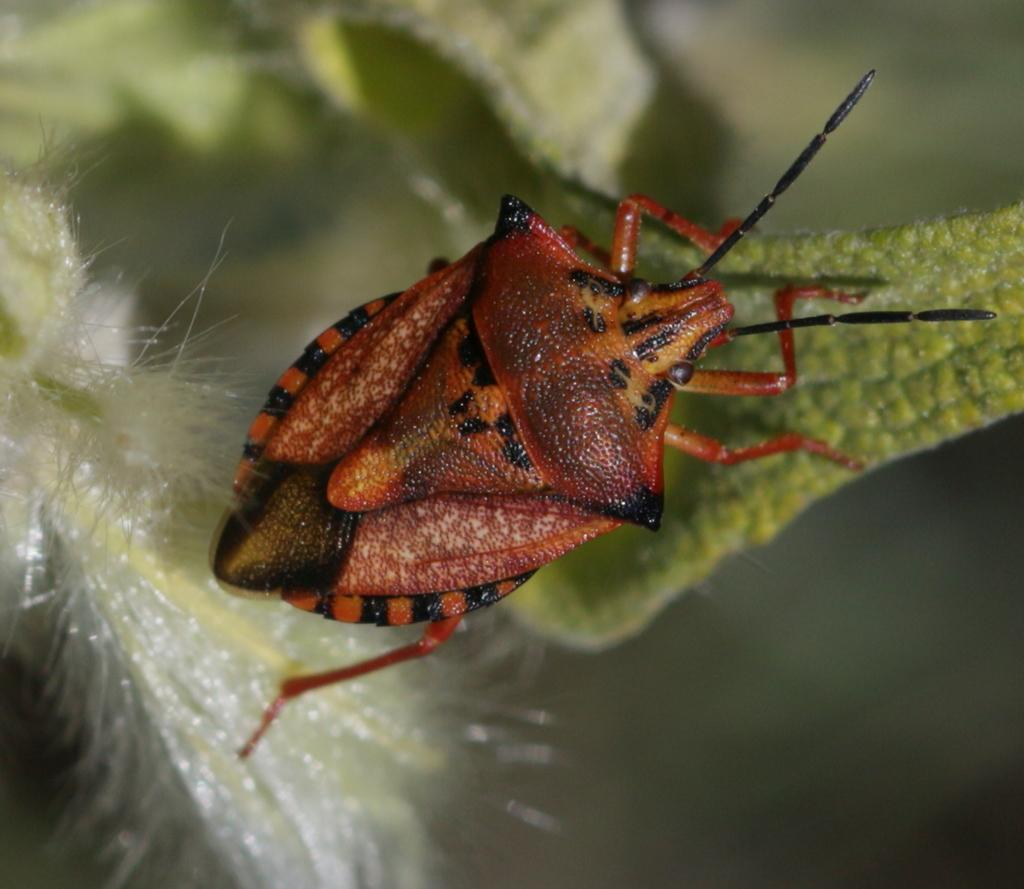What is present in the image? There is an insect in the image. Where is the insect located? The insect is on a leaf of a plant. Can you describe the background of the image? The background of the image is blurred. What type of pain is the insect experiencing in the image? There is no indication of pain in the image, and we cannot determine the insect's emotional state. 